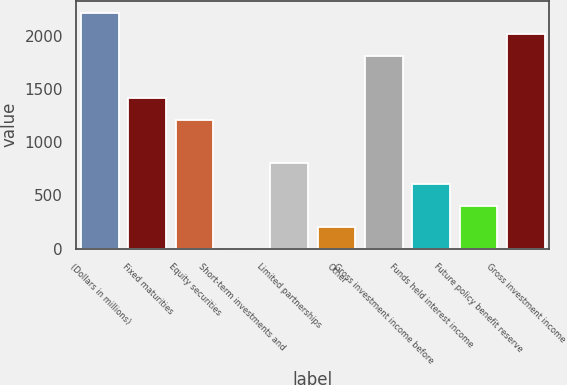Convert chart to OTSL. <chart><loc_0><loc_0><loc_500><loc_500><bar_chart><fcel>(Dollars in millions)<fcel>Fixed maturities<fcel>Equity securities<fcel>Short-term investments and<fcel>Limited partnerships<fcel>Other<fcel>Gross investment income before<fcel>Funds held interest income<fcel>Future policy benefit reserve<fcel>Gross investment income<nl><fcel>2216.38<fcel>1410.86<fcel>1209.48<fcel>1.2<fcel>806.72<fcel>202.58<fcel>1813.62<fcel>605.34<fcel>403.96<fcel>2015<nl></chart> 